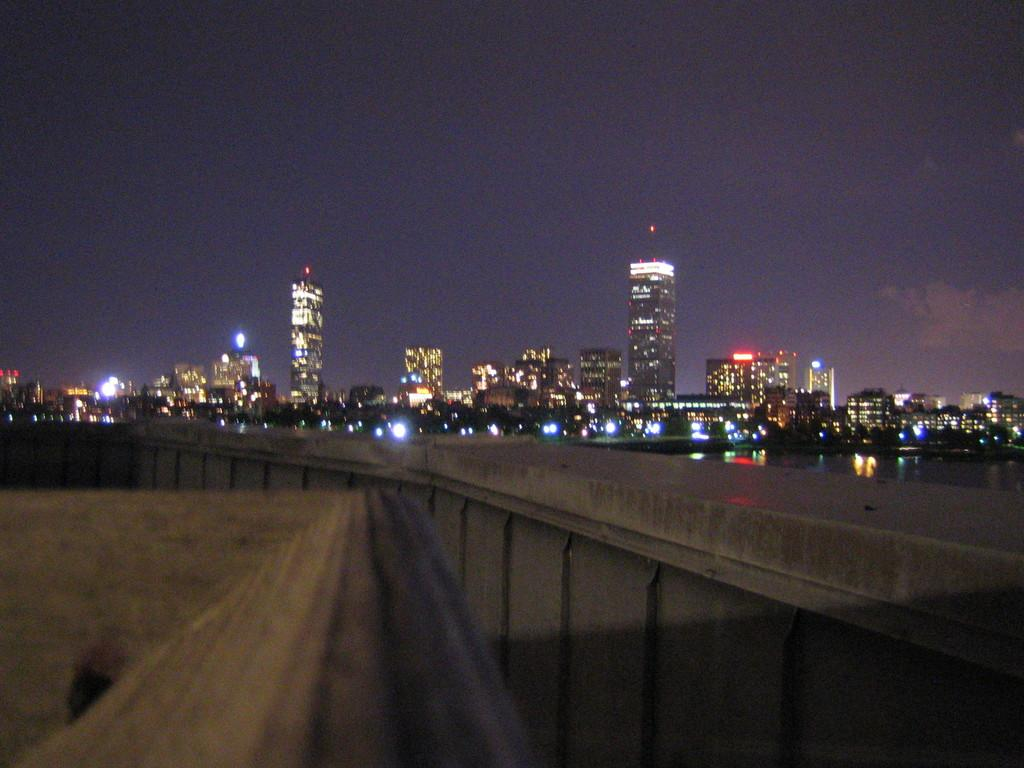What type of structure can be seen in the image? There is a compound wall in the image. How does the compound wall appear in the image? The compound wall extends from left to right in the image. What can be seen in the background of the image? There are buildings, trees, and lights visible in the background of the image. Is there any water visible in the image? Yes, there is water visible in the image. What type of paste is being used to hold the airplane together in the image? There is no airplane present in the image, so there is no need for any paste to hold it together. 